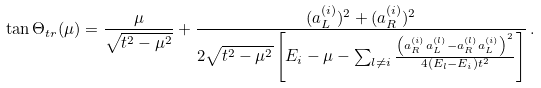Convert formula to latex. <formula><loc_0><loc_0><loc_500><loc_500>\tan \Theta _ { t r } ( \mu ) = \frac { \mu } { \sqrt { t ^ { 2 } - \mu ^ { 2 } } } + \frac { ( a ^ { ( i ) } _ { L } ) ^ { 2 } + ( a ^ { ( i ) } _ { R } ) ^ { 2 } } { 2 \sqrt { t ^ { 2 } - \mu ^ { 2 } } \left [ E _ { i } - \mu - \sum _ { l \neq i } \frac { \left ( a ^ { ( i ) } _ { R } a ^ { ( l ) } _ { L } - a ^ { ( l ) } _ { R } a ^ { ( i ) } _ { L } \right ) ^ { 2 } } { 4 ( E _ { l } - E _ { i } ) t ^ { 2 } } \right ] } \, .</formula> 